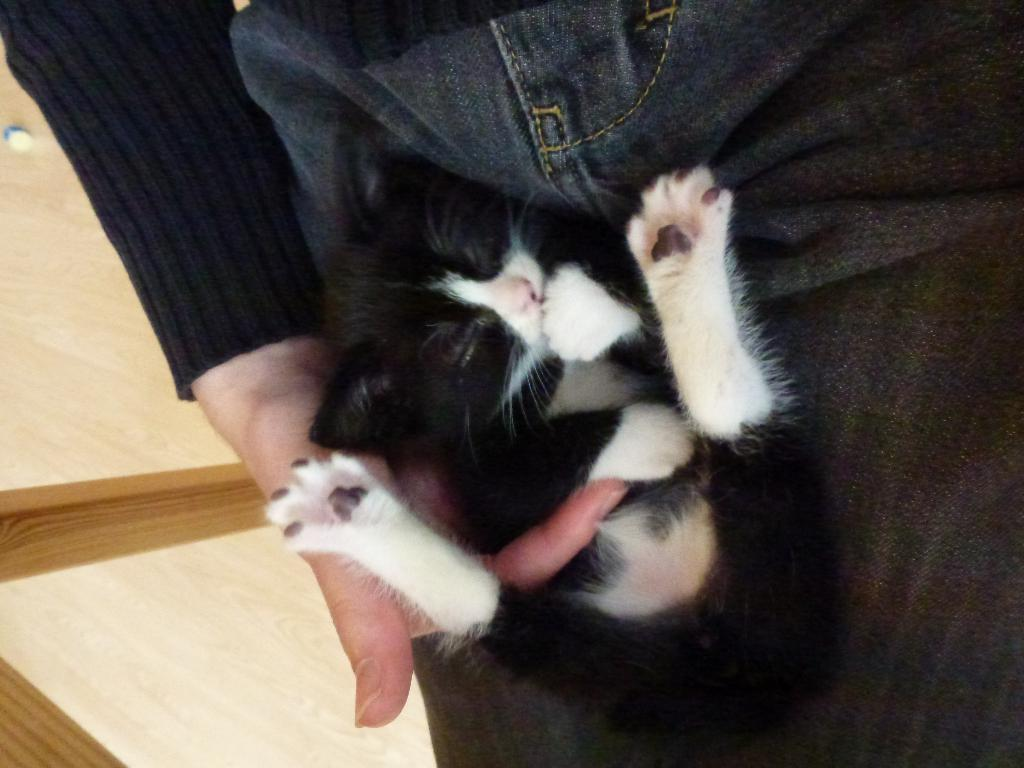What type of animal is in the image? There is a kitten in the image. What colors can be seen on the kitten? The kitten is black and white in color. Where is the kitten located in the image? The kitten is in the lap of a person. What type of meat is being served in the image? There is no meat present in the image; it features a kitten in the lap of a person. What kind of waste can be seen in the image? There is no waste present in the image; it features a kitten in the lap of a person. 